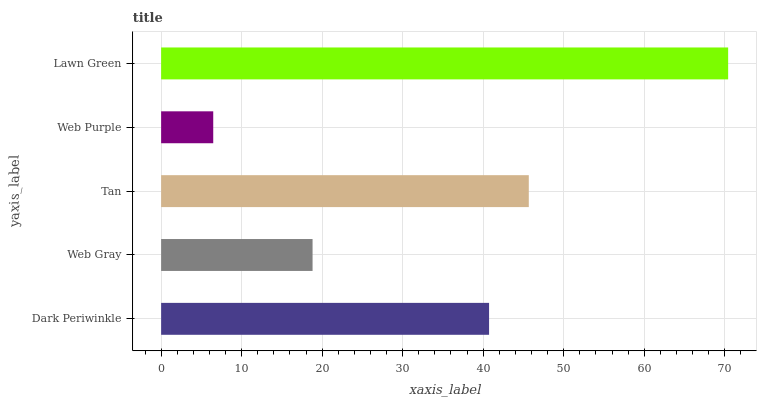Is Web Purple the minimum?
Answer yes or no. Yes. Is Lawn Green the maximum?
Answer yes or no. Yes. Is Web Gray the minimum?
Answer yes or no. No. Is Web Gray the maximum?
Answer yes or no. No. Is Dark Periwinkle greater than Web Gray?
Answer yes or no. Yes. Is Web Gray less than Dark Periwinkle?
Answer yes or no. Yes. Is Web Gray greater than Dark Periwinkle?
Answer yes or no. No. Is Dark Periwinkle less than Web Gray?
Answer yes or no. No. Is Dark Periwinkle the high median?
Answer yes or no. Yes. Is Dark Periwinkle the low median?
Answer yes or no. Yes. Is Tan the high median?
Answer yes or no. No. Is Tan the low median?
Answer yes or no. No. 